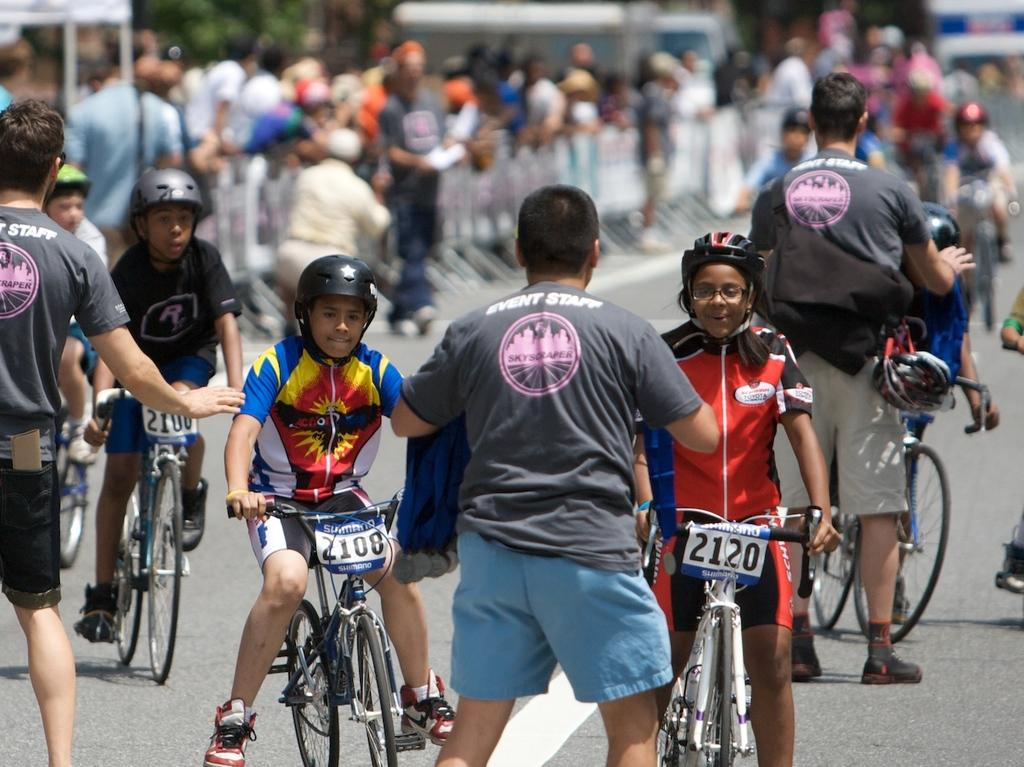What are the people in the image doing? The people in the image are on bicycles. What is the setting of the image? There is a road in the image. Are there any other people in the image besides those on bicycles? Yes, there are persons standing on the road. What type of thunder can be heard in the image? There is no sound present in the image, so it is not possible to determine if there is any thunder. 